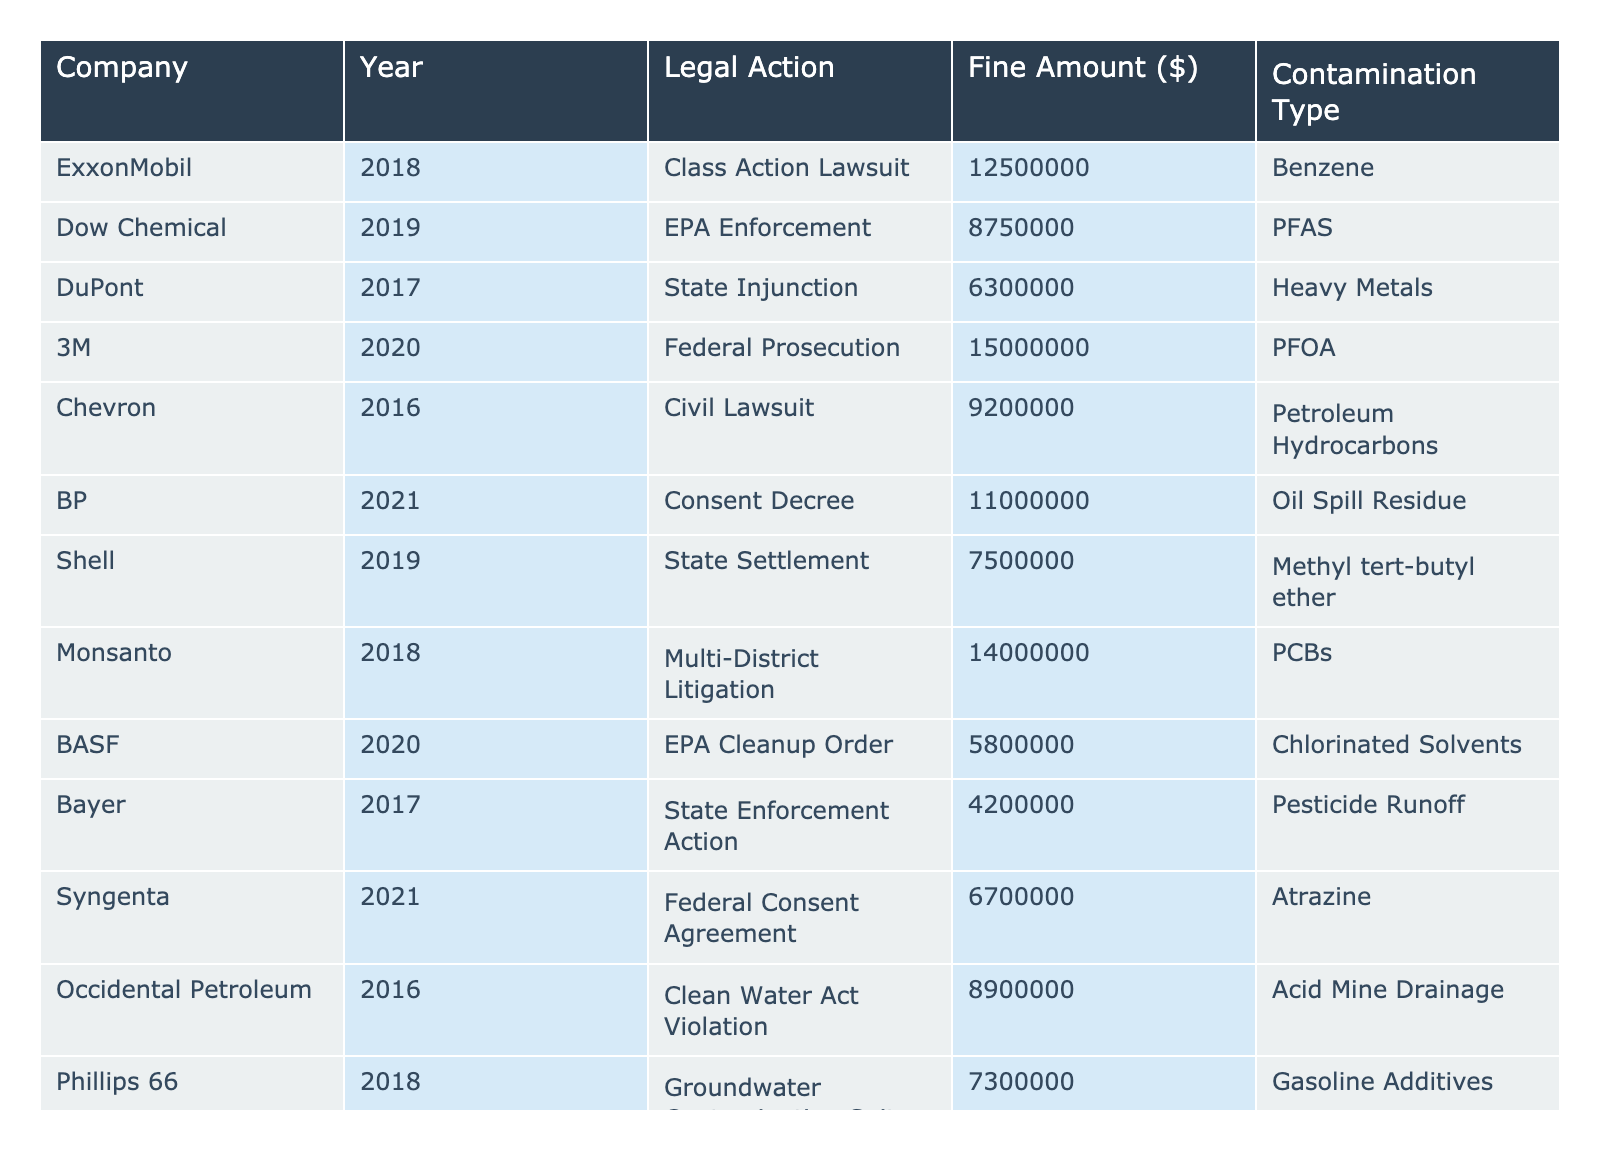What is the total fine amount for the companies penalized in 2020? The fine amounts for 2020 are $15,000,000 (3M), $5,100,000 (Huntsman Corporation), and $5,800,000 (BASF). Summing them gives $15,000,000 + $5,100,000 + $5,800,000 = $25,900,000.
Answer: $25,900,000 Which company received the highest fine amount? Upon reviewing the table, 3M received the highest fine of $15,000,000 for federal prosecution related to PFOA in 2020.
Answer: 3M Did any company receive a legal action related to pesticides? The table indicates that Bayer received an enforcement action for pesticide runoff, confirming that there was such a legal action.
Answer: Yes What is the average fine amount for lawsuits? The companies that were involved in lawsuits include ExxonMobil ($12,500,000), Chevron ($9,200,000), BP ($11,000,000), Monsanto ($14,000,000), and Huntsman Corporation ($5,100,000). Adding these fines gives $12,500,000 + $9,200,000 + $11,000,000 + $14,000,000 + $5,100,000 = $51,800,000. There are 5 companies, so the average is $51,800,000 / 5 = $10,360,000.
Answer: $10,360,000 How many companies were fined for contamination involving PFAS? The table shows Dow Chemical was fined $8,750,000 for PFAS contamination in 2019, which means there was only one company fined for PFAS.
Answer: 1 Which year saw the highest total fines based on the data? The years along with their total fines are: 2018: $19,500,000 (ExxonMobil + Phillips 66), 2019: $26,300,000 (Dow Chemical + Shell + Arkema), 2017: $10,800,000 (DuPont + Bayer), 2020: $25,900,000 (3M + BASF + Huntsman Corporation), 2021: $17,000,000 (BP + Syngenta). Adding these up shows 2019 had the highest total fines with $26,300,000.
Answer: 2019 Is there a company that was fined for chemical spills more than once? Reviewing the table, each company mentioned has a distinct legal action with unique contamination types, thus indicating no company has been fined for chemical spills more than once.
Answer: No What contamination type had the lowest fine amount? The lowest fine is $4,200,000 for pesticide runoff by Bayer. This indicates that among the different contamination types, pesticides had the lowest fine amount.
Answer: Pesticide Runoff 